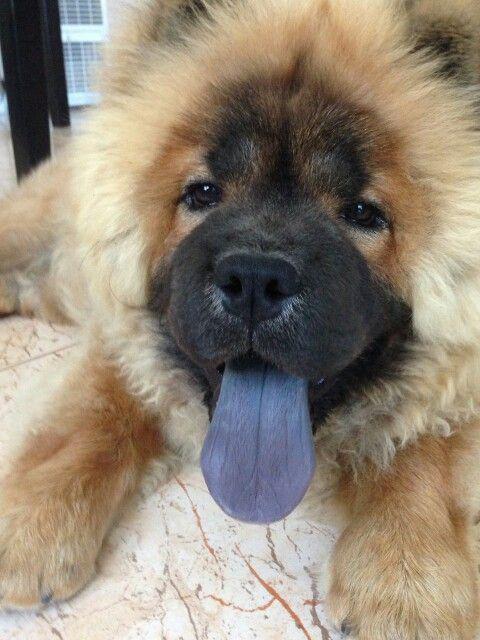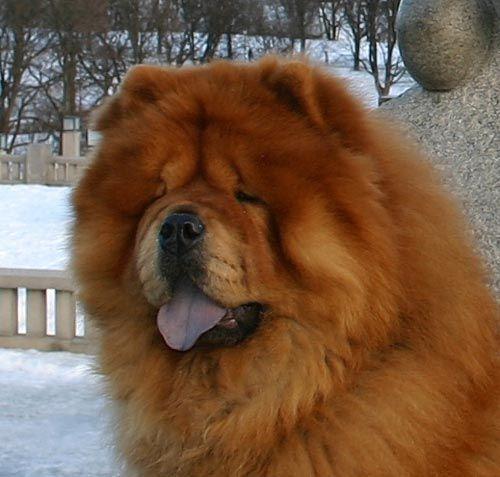The first image is the image on the left, the second image is the image on the right. Examine the images to the left and right. Is the description "An image shows only one dog, which is standing on grass and has a closed mouth." accurate? Answer yes or no. No. The first image is the image on the left, the second image is the image on the right. Evaluate the accuracy of this statement regarding the images: "The left image is a of a single dog standing on grass facing right.". Is it true? Answer yes or no. No. 